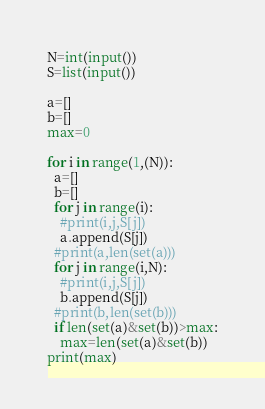Convert code to text. <code><loc_0><loc_0><loc_500><loc_500><_Python_>N=int(input())
S=list(input())

a=[]
b=[]
max=0

for i in range(1,(N)):
  a=[]
  b=[]
  for j in range(i):
    #print(i,j,S[j])
    a.append(S[j])
  #print(a,len(set(a)))
  for j in range(i,N):
    #print(i,j,S[j])
    b.append(S[j])
  #print(b,len(set(b)))
  if len(set(a)&set(b))>max:
    max=len(set(a)&set(b))
print(max)</code> 